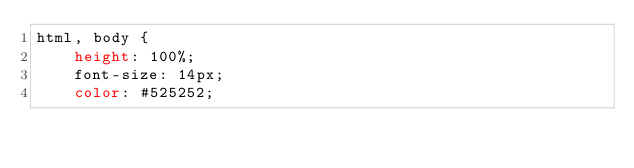<code> <loc_0><loc_0><loc_500><loc_500><_CSS_>html, body {
    height: 100%;
    font-size: 14px;
    color: #525252;</code> 